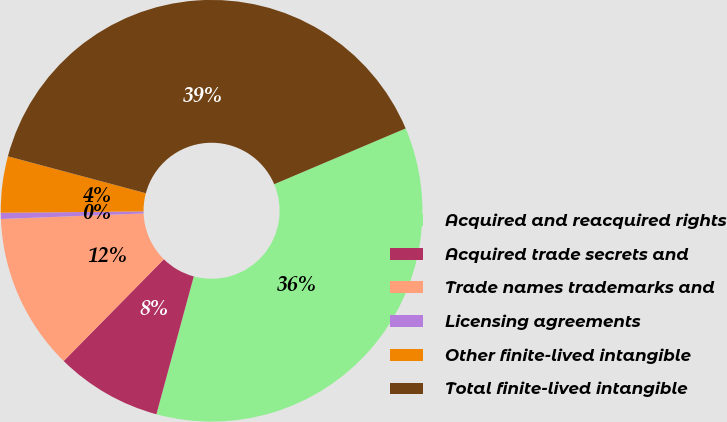Convert chart to OTSL. <chart><loc_0><loc_0><loc_500><loc_500><pie_chart><fcel>Acquired and reacquired rights<fcel>Acquired trade secrets and<fcel>Trade names trademarks and<fcel>Licensing agreements<fcel>Other finite-lived intangible<fcel>Total finite-lived intangible<nl><fcel>35.6%<fcel>8.16%<fcel>12.0%<fcel>0.47%<fcel>4.31%<fcel>39.45%<nl></chart> 